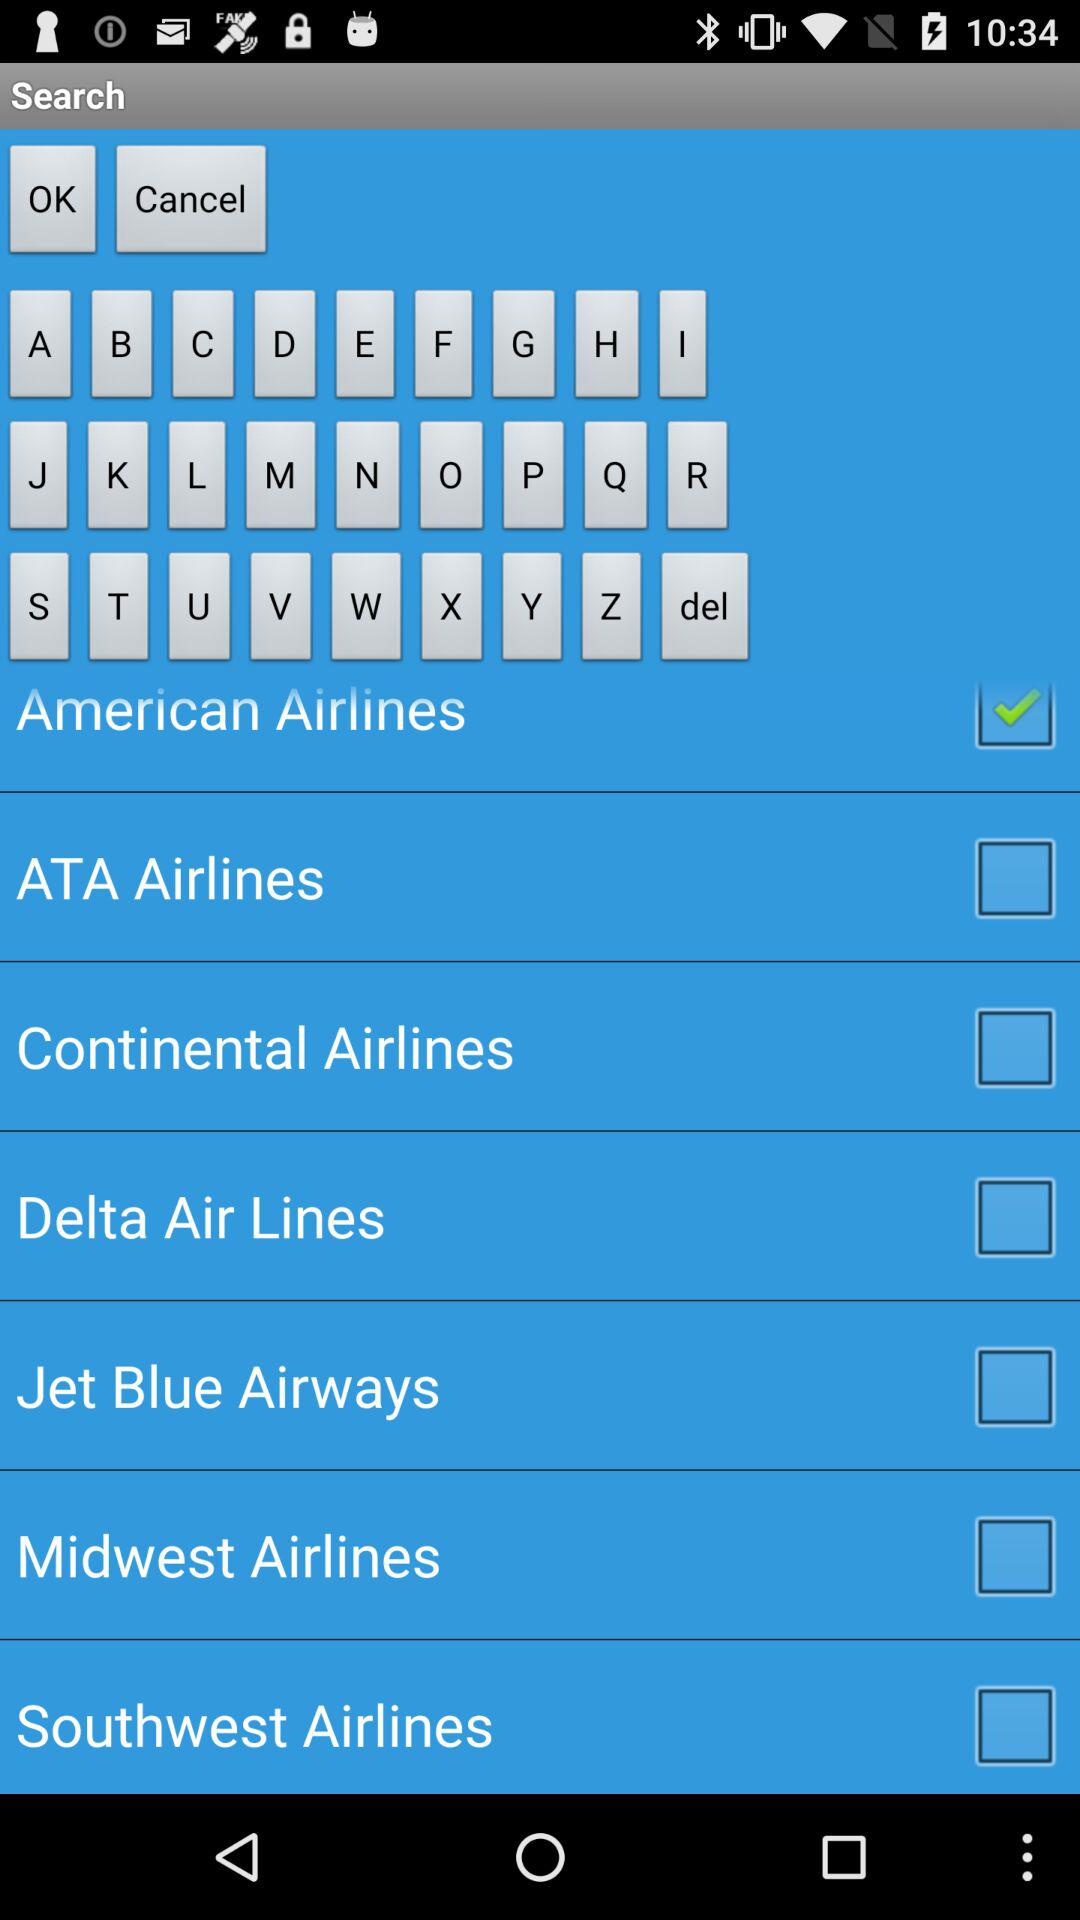What are the different displayed airlines? The different displayed airlines are "American Airlines", "ATA Airlines", "Continental Airlines", "Delta Air Lines", "Jet Blue Airways", "Midwest Airlines" and "Southwest Airlines". 